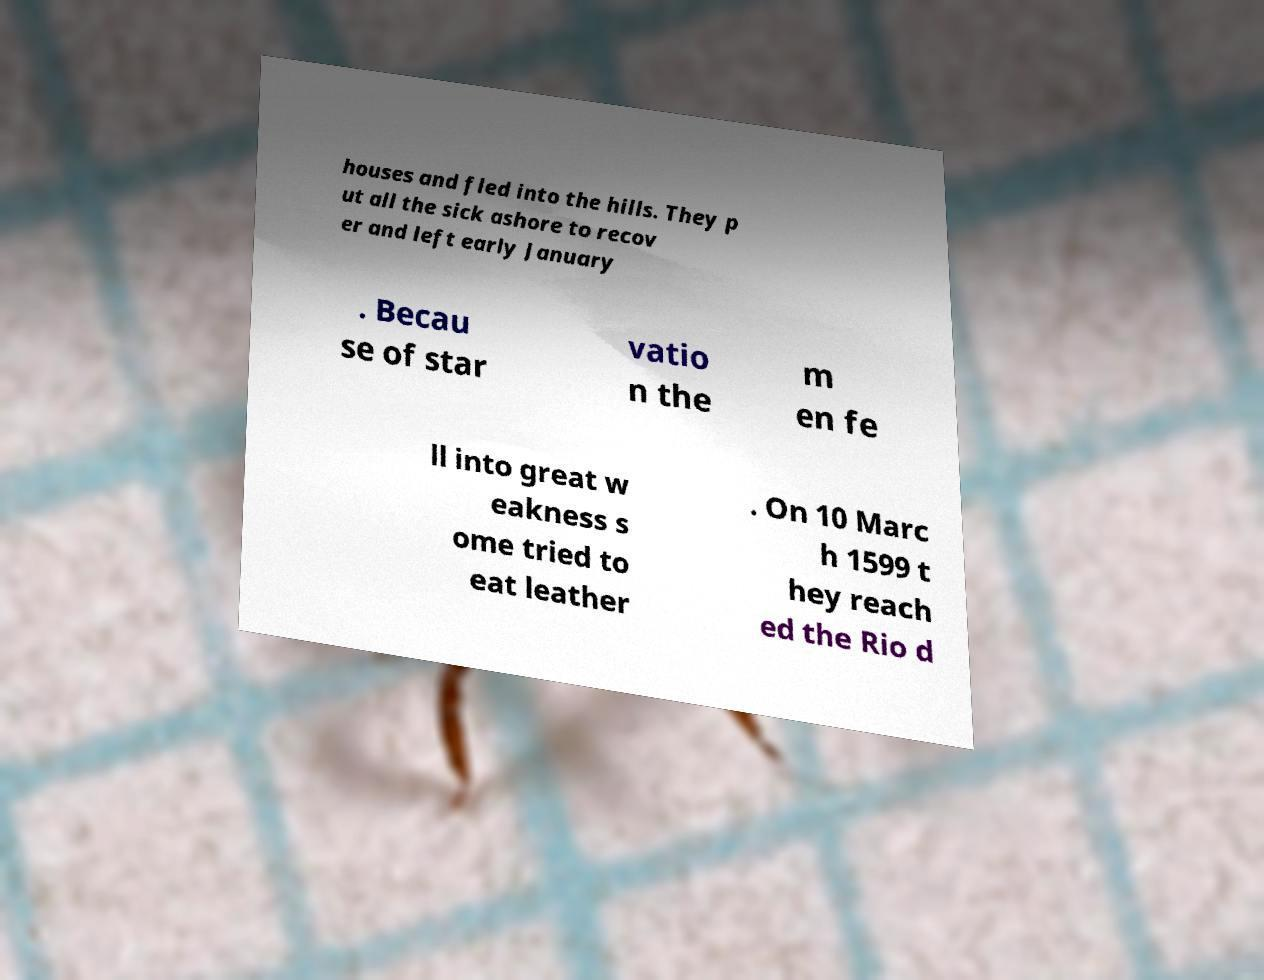I need the written content from this picture converted into text. Can you do that? houses and fled into the hills. They p ut all the sick ashore to recov er and left early January . Becau se of star vatio n the m en fe ll into great w eakness s ome tried to eat leather . On 10 Marc h 1599 t hey reach ed the Rio d 